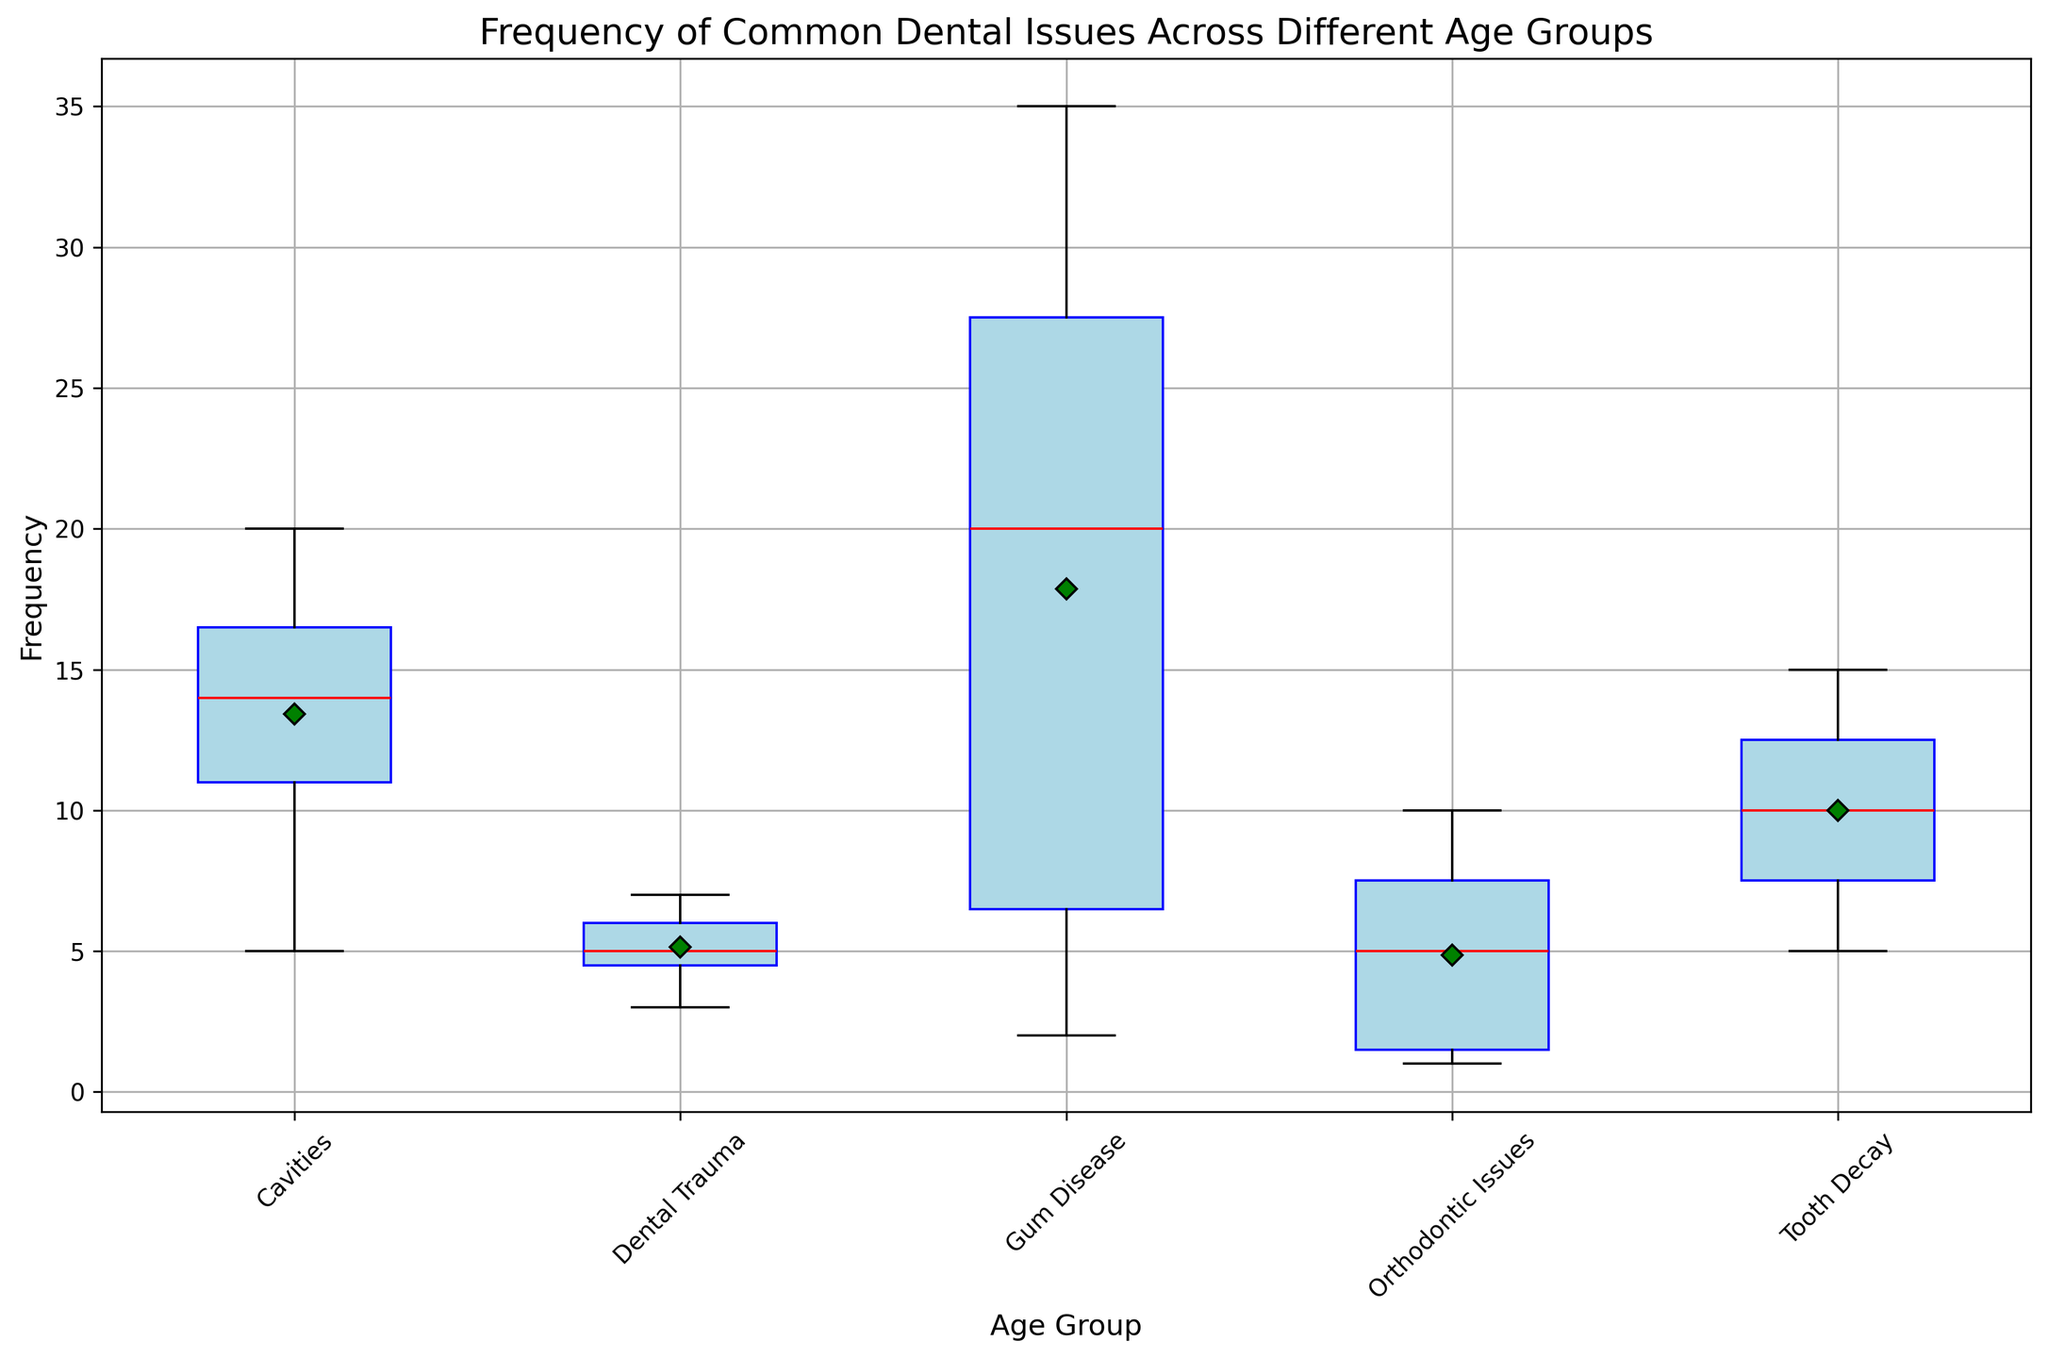Which age group has the highest mean frequency of Gum Disease? The mean frequency of Gum Disease is represented by the green diamond marker on the box plot. By observing the green diamonds for each age group, the highest one is noted.
Answer: 71+ What's the median value for the frequency of Cavities in different age groups? The median value is shown as a red line within each box in the box plot. By identifying the red lines within the boxes corresponding to the Cavities data across age groups, the median value can be determined.
Answer: 14 How does the frequency of Orthodontic Issues compare between the 6-12 and 13-19 age groups? The comparison is made by observing the heights of the boxes for Orthodontic Issues related to the 6-12 and 13-19 age groups. The position of the boxes, marked positions for median, mean, and other statistics, need to be compared for both groups.
Answer: 13-19 > 6-12 Which age group exhibits the highest variability in Gum Disease frequency? The variability can be gauged by looking at the range between the top and bottom whiskers of the box plot for Gum Disease across all age groups. The age group with the widest range shows the highest variability.
Answer: 71+ What's the mean frequency of Tooth Decay compared to the median frequency for the age group 20-35? To determine this, look at the green diamond marker for the mean frequency and the red line for the median frequency within the 20-35 box for Tooth Decay in the box plot.
Answer: Mean > Median Among the dental issues, which one shows the least frequency variability in the Age Group 0-5? For each dental issue within the 0-5 age group, observe the range between the top and bottom whiskers. The issue with the shortest range indicates the least variability.
Answer: Orthodontic Issues How does the median frequency of Dental Trauma change from the 0-5 age group to the 51-70 age group? Look at the position of the red median line for Dental Trauma in both the 0-5 and 51-70 age groups and compare the values.
Answer: 0-5 < 51-70 What is the frequency range for Gum Disease in the 36-50 age group? The frequency range is determined by identifying the values at the top and bottom whiskers for the Gum Disease box in the 36-50 age group and subtracting the minimum value from the maximum value.
Answer: 25 – 15 = 10 